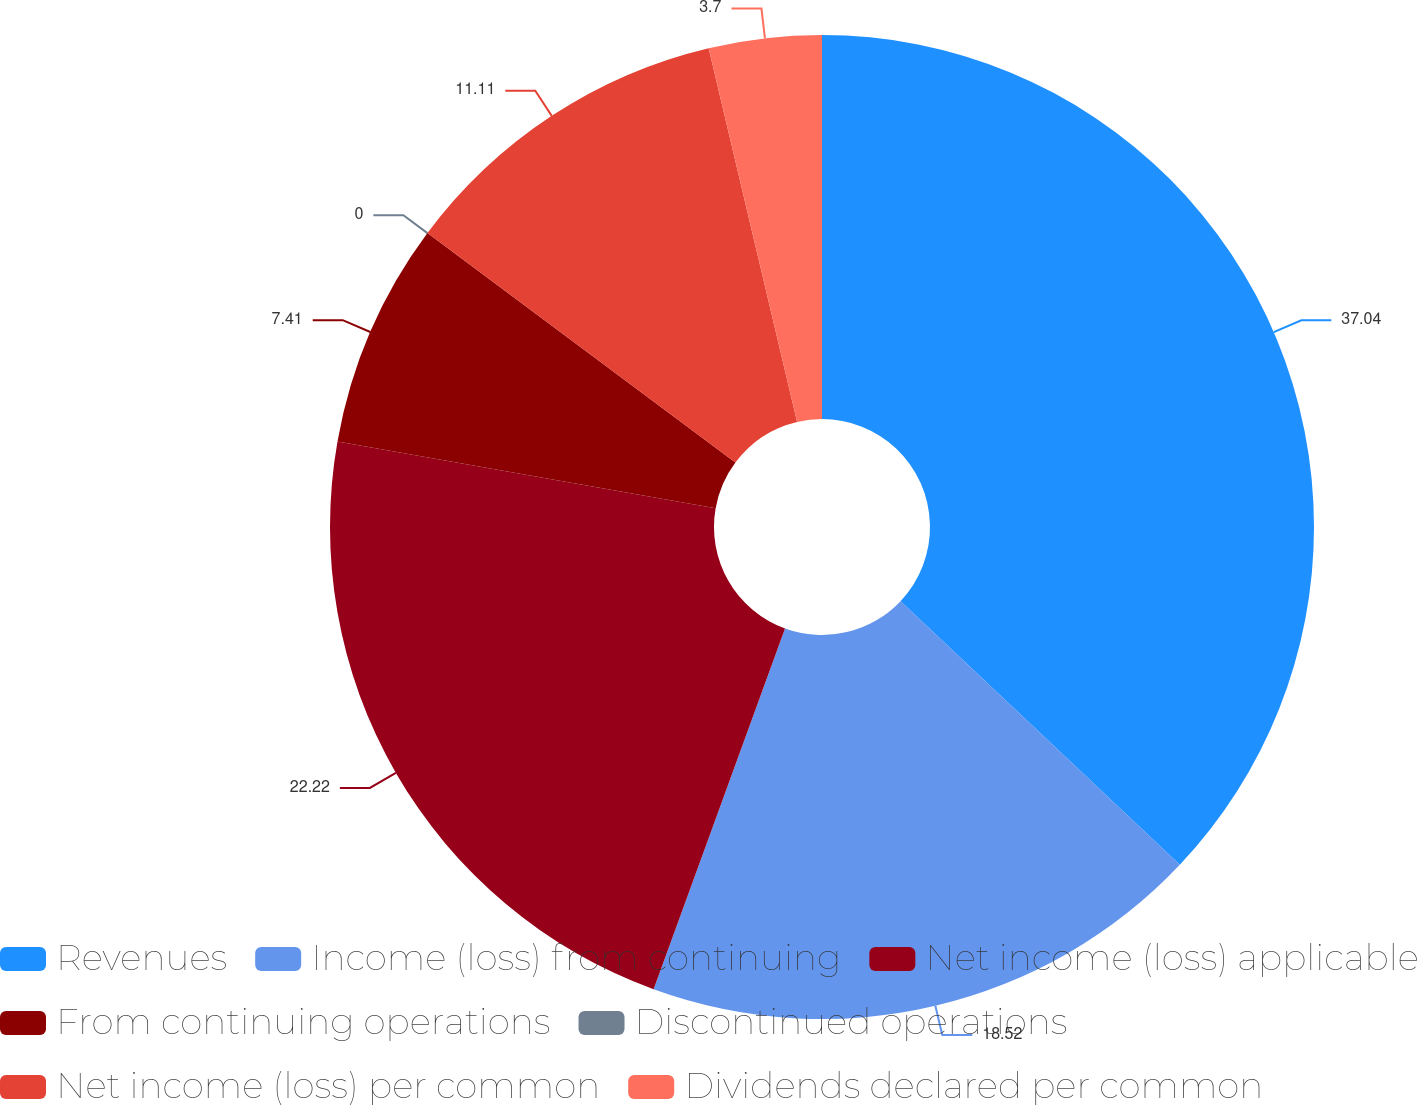Convert chart to OTSL. <chart><loc_0><loc_0><loc_500><loc_500><pie_chart><fcel>Revenues<fcel>Income (loss) from continuing<fcel>Net income (loss) applicable<fcel>From continuing operations<fcel>Discontinued operations<fcel>Net income (loss) per common<fcel>Dividends declared per common<nl><fcel>37.04%<fcel>18.52%<fcel>22.22%<fcel>7.41%<fcel>0.0%<fcel>11.11%<fcel>3.7%<nl></chart> 